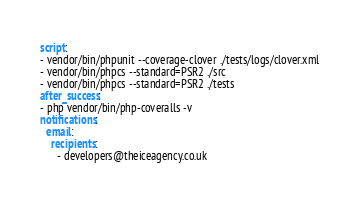<code> <loc_0><loc_0><loc_500><loc_500><_YAML_>script:
- vendor/bin/phpunit --coverage-clover ./tests/logs/clover.xml
- vendor/bin/phpcs --standard=PSR2 ./src
- vendor/bin/phpcs --standard=PSR2 ./tests
after_success:
- php vendor/bin/php-coveralls -v
notifications:
  email:
    recipients:
      - developers@theiceagency.co.uk
</code> 